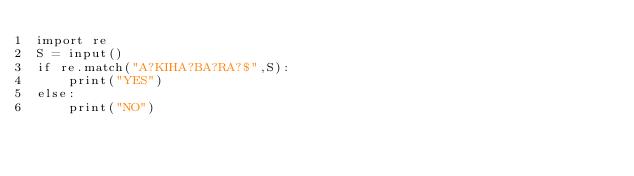Convert code to text. <code><loc_0><loc_0><loc_500><loc_500><_Python_>import re
S = input()
if re.match("A?KIHA?BA?RA?$",S):
    print("YES")
else:
    print("NO")</code> 